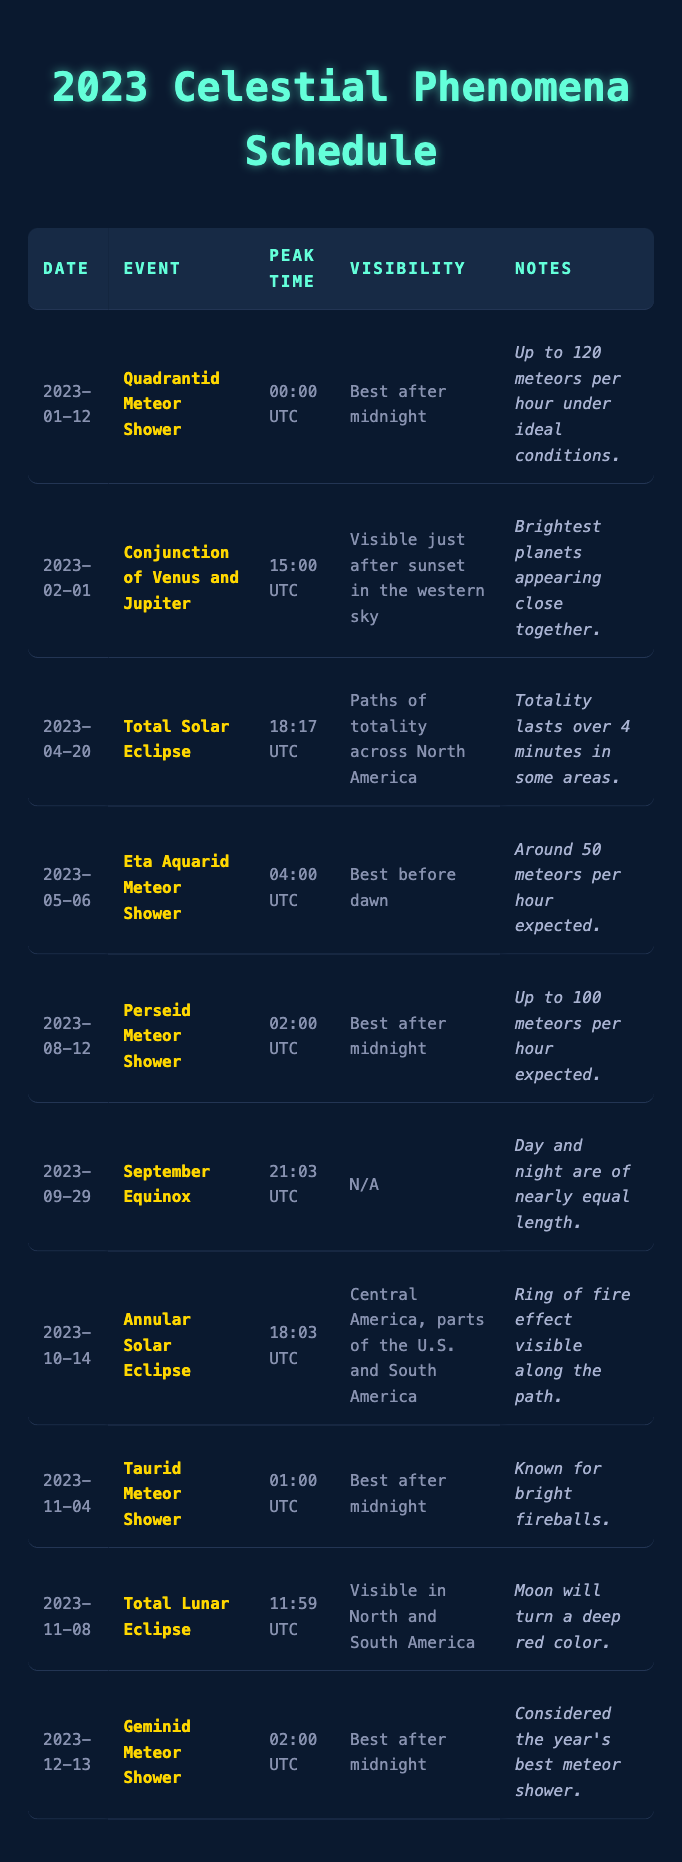What is the date of the Perseid Meteor Shower? The table lists the events along with their respective dates. The Perseid Meteor Shower is shown with the date 2023-08-12.
Answer: 2023-08-12 What is the visibility condition for the Total Lunar Eclipse? The Total Lunar Eclipse is listed in the table with the specific visibility condition "Visible in North and South America."
Answer: Visible in North and South America How many meteors per hour can be expected during the Quadrantid Meteor Shower? The notes for the Quadrantid Meteor Shower specify that up to 120 meteors per hour can be expected under ideal conditions.
Answer: Up to 120 meteors per hour What is the peak time of the Annular Solar Eclipse? The table indicates the peak time for the Annular Solar Eclipse as 18:03 UTC.
Answer: 18:03 UTC How many meteor showers are listed after the date of the Total Solar Eclipse? The Total Solar Eclipse date is 2023-04-20. Looking at the table, there are four meteor showers listed after this date: Eta Aquarid, Perseid, Taurid, and Geminid showers.
Answer: Four Which event has the longest peak time listed? The Total Solar Eclipse allows for a peak time of 18:17 UTC, whereas the other events have shorter peak times. Therefore, it has the longest peak time.
Answer: Total Solar Eclipse What is the significance of the September Equinox event? The September Equinox indicates that day and night are nearly of equal length, as noted in the table.
Answer: Day and night are nearly equal in length On which date can we expect the maximum visibility for the Eta Aquarid Meteor Shower? The best visibility for the Eta Aquarid Meteor Shower is noted as being before dawn, which will occur on the date 2023-05-06.
Answer: 2023-05-06 Is there any event in the table that occurs in December? Yes, the Geminid Meteor Shower is mentioned in the table, which takes place on December 13, 2023.
Answer: Yes If you were to rank the meteor showers listed in terms of meteor rate observed per hour, which would come out on top? Comparing the meteor rates, the Quadrantid Meteor Shower has 120 meteors per hour, followed by the Perseids with 100, and then the Eta Aquarids with around 50. Thus, the Quadrantid is ranked highest.
Answer: Quadrantid Meteor Shower How many events related to solar eclipses are present in the table? When reviewing the table, there are two solar eclipse events mentioned: the Total Solar Eclipse and the Annular Solar Eclipse.
Answer: Two 